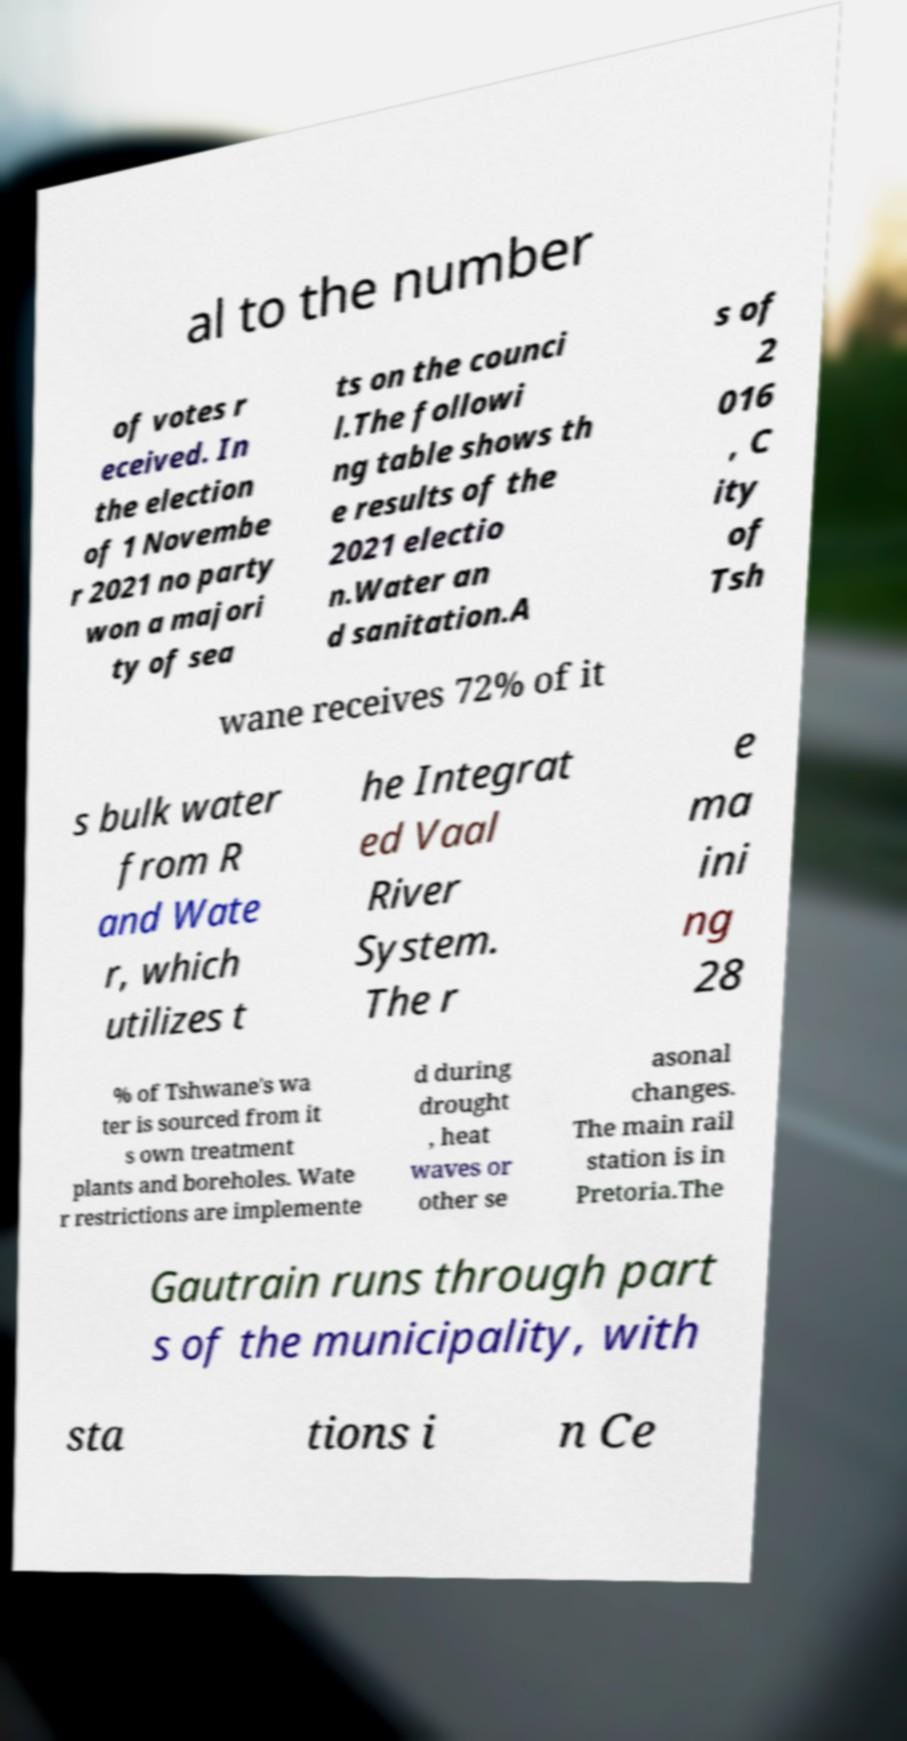Can you read and provide the text displayed in the image?This photo seems to have some interesting text. Can you extract and type it out for me? al to the number of votes r eceived. In the election of 1 Novembe r 2021 no party won a majori ty of sea ts on the counci l.The followi ng table shows th e results of the 2021 electio n.Water an d sanitation.A s of 2 016 , C ity of Tsh wane receives 72% of it s bulk water from R and Wate r, which utilizes t he Integrat ed Vaal River System. The r e ma ini ng 28 % of Tshwane's wa ter is sourced from it s own treatment plants and boreholes. Wate r restrictions are implemente d during drought , heat waves or other se asonal changes. The main rail station is in Pretoria.The Gautrain runs through part s of the municipality, with sta tions i n Ce 